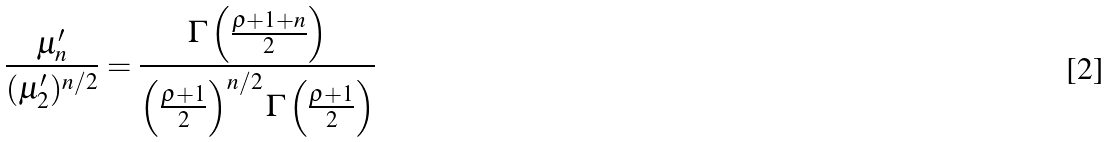<formula> <loc_0><loc_0><loc_500><loc_500>\frac { \mu _ { n } ^ { \prime } } { ( \mu _ { 2 } ^ { \prime } ) ^ { n / 2 } } = \frac { \Gamma \left ( \frac { \varrho + 1 + n } { 2 } \right ) } { \left ( \frac { \varrho + 1 } { 2 } \right ) ^ { n / 2 } \Gamma \left ( \frac { \varrho + 1 } { 2 } \right ) }</formula> 